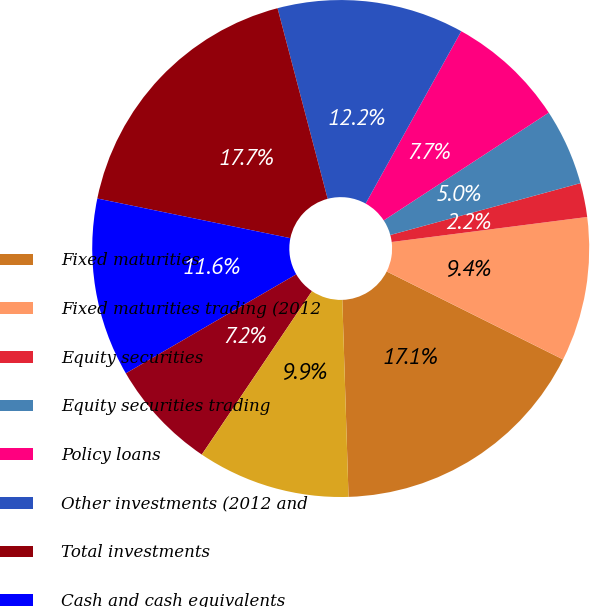Convert chart to OTSL. <chart><loc_0><loc_0><loc_500><loc_500><pie_chart><fcel>Fixed maturities<fcel>Fixed maturities trading (2012<fcel>Equity securities<fcel>Equity securities trading<fcel>Policy loans<fcel>Other investments (2012 and<fcel>Total investments<fcel>Cash and cash equivalents<fcel>Accrued investment income<fcel>Premiums due and other<nl><fcel>17.13%<fcel>9.39%<fcel>2.21%<fcel>4.97%<fcel>7.73%<fcel>12.15%<fcel>17.68%<fcel>11.6%<fcel>7.18%<fcel>9.94%<nl></chart> 